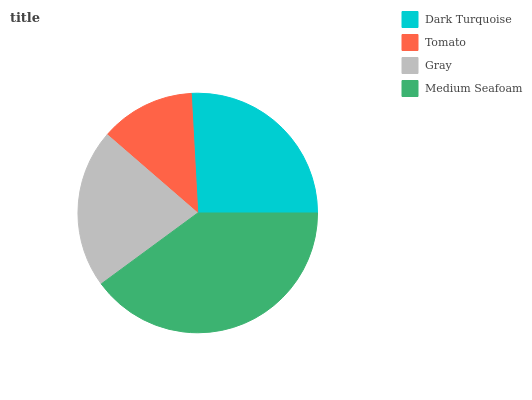Is Tomato the minimum?
Answer yes or no. Yes. Is Medium Seafoam the maximum?
Answer yes or no. Yes. Is Gray the minimum?
Answer yes or no. No. Is Gray the maximum?
Answer yes or no. No. Is Gray greater than Tomato?
Answer yes or no. Yes. Is Tomato less than Gray?
Answer yes or no. Yes. Is Tomato greater than Gray?
Answer yes or no. No. Is Gray less than Tomato?
Answer yes or no. No. Is Dark Turquoise the high median?
Answer yes or no. Yes. Is Gray the low median?
Answer yes or no. Yes. Is Medium Seafoam the high median?
Answer yes or no. No. Is Medium Seafoam the low median?
Answer yes or no. No. 